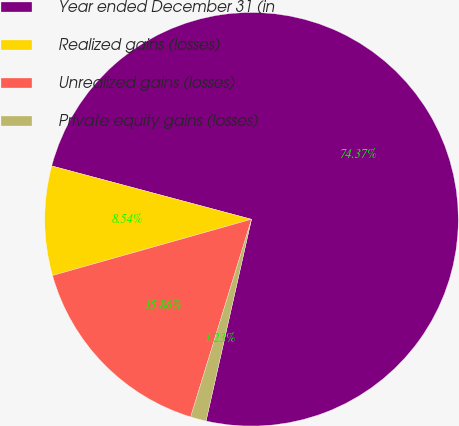Convert chart. <chart><loc_0><loc_0><loc_500><loc_500><pie_chart><fcel>Year ended December 31 (in<fcel>Realized gains (losses)<fcel>Unrealized gains (losses)<fcel>Private equity gains (losses)<nl><fcel>74.38%<fcel>8.54%<fcel>15.86%<fcel>1.23%<nl></chart> 